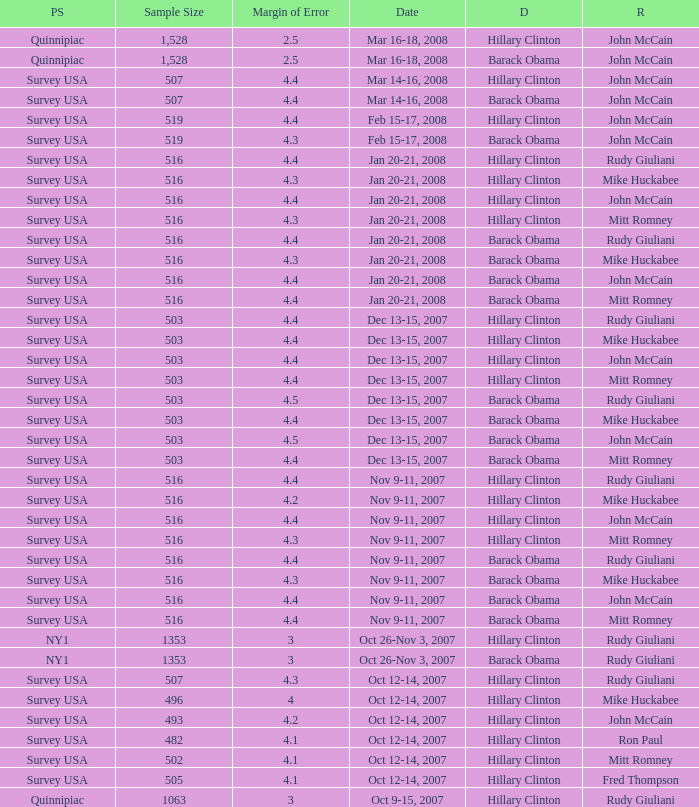When was the poll conducted, which had a sample size of 496 and featured republican mike huckabee as the chosen candidate? Oct 12-14, 2007. 